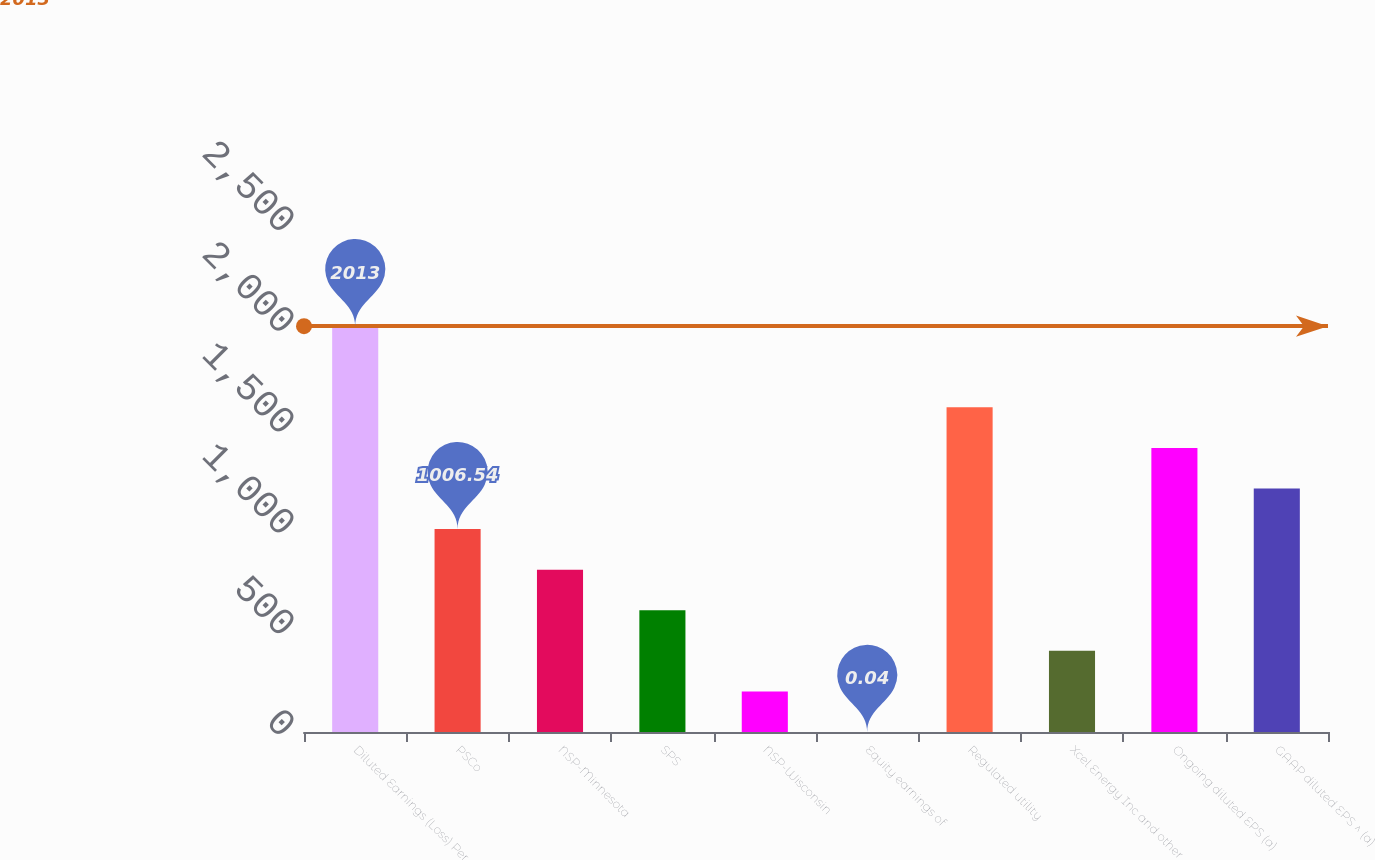Convert chart. <chart><loc_0><loc_0><loc_500><loc_500><bar_chart><fcel>Diluted Earnings (Loss) Per<fcel>PSCo<fcel>NSP-Minnesota<fcel>SPS<fcel>NSP-Wisconsin<fcel>Equity earnings of<fcel>Regulated utility<fcel>Xcel Energy Inc and other<fcel>Ongoing diluted EPS (a)<fcel>GAAP diluted EPS ^ (a)<nl><fcel>2013<fcel>1006.54<fcel>805.24<fcel>603.94<fcel>201.34<fcel>0.04<fcel>1610.44<fcel>402.64<fcel>1409.14<fcel>1207.84<nl></chart> 